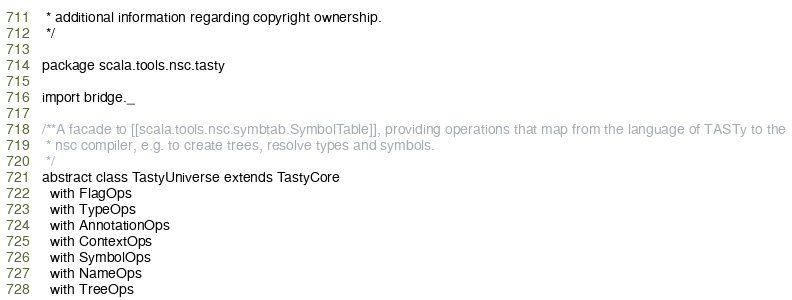<code> <loc_0><loc_0><loc_500><loc_500><_Scala_> * additional information regarding copyright ownership.
 */

package scala.tools.nsc.tasty

import bridge._

/**A facade to [[scala.tools.nsc.symbtab.SymbolTable]], providing operations that map from the language of TASTy to the
 * nsc compiler, e.g. to create trees, resolve types and symbols.
 */
abstract class TastyUniverse extends TastyCore
  with FlagOps
  with TypeOps
  with AnnotationOps
  with ContextOps
  with SymbolOps
  with NameOps
  with TreeOps
</code> 